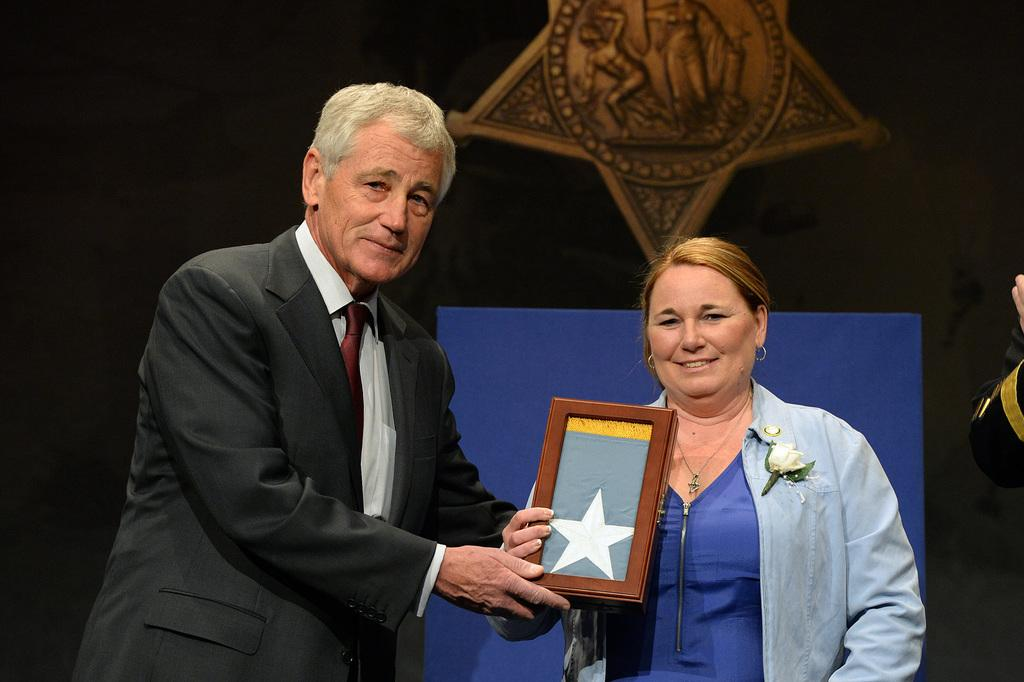Who is the main subject in the image? There is a person in the center of the image. What is the person wearing? The person is wearing a black suit. Who is standing beside the person? There is a lady beside the person. What is the lady wearing? The lady is wearing a denim jacket. What color is the background of the image? The background of the image is black. What type of lace can be seen on the person's clothing in the image? There is no lace visible on the person's clothing in the image. Is the lady holding a quill in her hand in the image? There is no quill present in the image. 